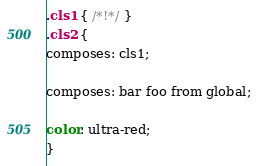<code> <loc_0><loc_0><loc_500><loc_500><_CSS_>.cls1 { /*!*/ }
.cls2 {
composes: cls1;

composes: bar foo from global;

color: ultra-red;
}</code> 